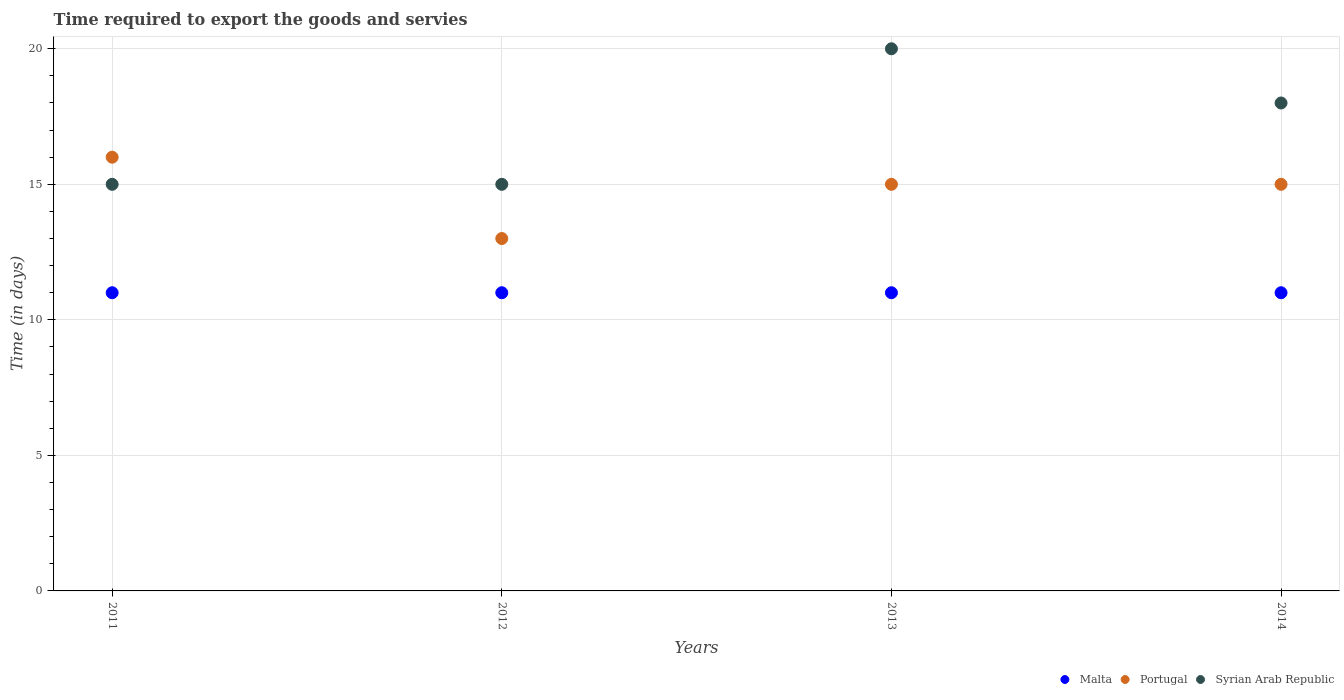How many different coloured dotlines are there?
Offer a terse response. 3. What is the number of days required to export the goods and services in Portugal in 2012?
Ensure brevity in your answer.  13. Across all years, what is the maximum number of days required to export the goods and services in Malta?
Keep it short and to the point. 11. In which year was the number of days required to export the goods and services in Malta minimum?
Keep it short and to the point. 2011. What is the total number of days required to export the goods and services in Portugal in the graph?
Your response must be concise. 59. In the year 2013, what is the difference between the number of days required to export the goods and services in Syrian Arab Republic and number of days required to export the goods and services in Portugal?
Keep it short and to the point. 5. In how many years, is the number of days required to export the goods and services in Syrian Arab Republic greater than 8 days?
Make the answer very short. 4. What is the ratio of the number of days required to export the goods and services in Syrian Arab Republic in 2012 to that in 2014?
Offer a terse response. 0.83. Is the number of days required to export the goods and services in Malta in 2011 less than that in 2014?
Your answer should be compact. No. What is the difference between the highest and the lowest number of days required to export the goods and services in Malta?
Your answer should be compact. 0. Is it the case that in every year, the sum of the number of days required to export the goods and services in Malta and number of days required to export the goods and services in Portugal  is greater than the number of days required to export the goods and services in Syrian Arab Republic?
Offer a terse response. Yes. Is the number of days required to export the goods and services in Malta strictly greater than the number of days required to export the goods and services in Portugal over the years?
Your answer should be compact. No. Is the number of days required to export the goods and services in Malta strictly less than the number of days required to export the goods and services in Syrian Arab Republic over the years?
Provide a short and direct response. Yes. How many dotlines are there?
Ensure brevity in your answer.  3. Are the values on the major ticks of Y-axis written in scientific E-notation?
Offer a very short reply. No. Does the graph contain any zero values?
Your answer should be compact. No. Does the graph contain grids?
Your response must be concise. Yes. Where does the legend appear in the graph?
Keep it short and to the point. Bottom right. What is the title of the graph?
Your answer should be very brief. Time required to export the goods and servies. Does "Kosovo" appear as one of the legend labels in the graph?
Ensure brevity in your answer.  No. What is the label or title of the X-axis?
Your response must be concise. Years. What is the label or title of the Y-axis?
Your response must be concise. Time (in days). What is the Time (in days) in Malta in 2011?
Make the answer very short. 11. What is the Time (in days) of Portugal in 2011?
Keep it short and to the point. 16. What is the Time (in days) in Syrian Arab Republic in 2011?
Make the answer very short. 15. What is the Time (in days) of Portugal in 2012?
Offer a very short reply. 13. What is the Time (in days) of Malta in 2013?
Ensure brevity in your answer.  11. What is the Time (in days) in Malta in 2014?
Your answer should be compact. 11. What is the Time (in days) of Portugal in 2014?
Your answer should be compact. 15. Across all years, what is the maximum Time (in days) in Malta?
Offer a terse response. 11. Across all years, what is the maximum Time (in days) of Portugal?
Your response must be concise. 16. What is the total Time (in days) in Malta in the graph?
Make the answer very short. 44. What is the total Time (in days) in Syrian Arab Republic in the graph?
Offer a terse response. 68. What is the difference between the Time (in days) in Malta in 2011 and that in 2012?
Give a very brief answer. 0. What is the difference between the Time (in days) in Malta in 2011 and that in 2013?
Your answer should be very brief. 0. What is the difference between the Time (in days) in Portugal in 2011 and that in 2013?
Keep it short and to the point. 1. What is the difference between the Time (in days) in Malta in 2011 and that in 2014?
Ensure brevity in your answer.  0. What is the difference between the Time (in days) of Syrian Arab Republic in 2011 and that in 2014?
Your answer should be compact. -3. What is the difference between the Time (in days) of Portugal in 2012 and that in 2013?
Your answer should be very brief. -2. What is the difference between the Time (in days) of Malta in 2012 and that in 2014?
Give a very brief answer. 0. What is the difference between the Time (in days) of Portugal in 2013 and that in 2014?
Your answer should be very brief. 0. What is the difference between the Time (in days) of Malta in 2011 and the Time (in days) of Syrian Arab Republic in 2012?
Your response must be concise. -4. What is the difference between the Time (in days) of Portugal in 2011 and the Time (in days) of Syrian Arab Republic in 2012?
Offer a very short reply. 1. What is the difference between the Time (in days) in Portugal in 2011 and the Time (in days) in Syrian Arab Republic in 2013?
Your answer should be compact. -4. What is the difference between the Time (in days) in Malta in 2011 and the Time (in days) in Portugal in 2014?
Provide a short and direct response. -4. What is the difference between the Time (in days) in Malta in 2011 and the Time (in days) in Syrian Arab Republic in 2014?
Your response must be concise. -7. What is the difference between the Time (in days) in Portugal in 2011 and the Time (in days) in Syrian Arab Republic in 2014?
Your response must be concise. -2. What is the difference between the Time (in days) in Malta in 2012 and the Time (in days) in Portugal in 2013?
Make the answer very short. -4. What is the difference between the Time (in days) of Malta in 2012 and the Time (in days) of Portugal in 2014?
Provide a succinct answer. -4. What is the difference between the Time (in days) in Portugal in 2012 and the Time (in days) in Syrian Arab Republic in 2014?
Keep it short and to the point. -5. What is the difference between the Time (in days) of Malta in 2013 and the Time (in days) of Portugal in 2014?
Your answer should be compact. -4. What is the difference between the Time (in days) in Malta in 2013 and the Time (in days) in Syrian Arab Republic in 2014?
Your response must be concise. -7. What is the average Time (in days) in Portugal per year?
Ensure brevity in your answer.  14.75. What is the average Time (in days) of Syrian Arab Republic per year?
Provide a short and direct response. 17. In the year 2011, what is the difference between the Time (in days) in Malta and Time (in days) in Syrian Arab Republic?
Provide a succinct answer. -4. In the year 2012, what is the difference between the Time (in days) in Malta and Time (in days) in Portugal?
Your answer should be very brief. -2. In the year 2012, what is the difference between the Time (in days) in Portugal and Time (in days) in Syrian Arab Republic?
Make the answer very short. -2. In the year 2013, what is the difference between the Time (in days) in Malta and Time (in days) in Syrian Arab Republic?
Provide a succinct answer. -9. In the year 2014, what is the difference between the Time (in days) of Malta and Time (in days) of Portugal?
Give a very brief answer. -4. In the year 2014, what is the difference between the Time (in days) of Malta and Time (in days) of Syrian Arab Republic?
Offer a very short reply. -7. In the year 2014, what is the difference between the Time (in days) of Portugal and Time (in days) of Syrian Arab Republic?
Offer a terse response. -3. What is the ratio of the Time (in days) in Malta in 2011 to that in 2012?
Offer a very short reply. 1. What is the ratio of the Time (in days) of Portugal in 2011 to that in 2012?
Provide a short and direct response. 1.23. What is the ratio of the Time (in days) in Syrian Arab Republic in 2011 to that in 2012?
Your answer should be compact. 1. What is the ratio of the Time (in days) of Malta in 2011 to that in 2013?
Your response must be concise. 1. What is the ratio of the Time (in days) of Portugal in 2011 to that in 2013?
Your answer should be very brief. 1.07. What is the ratio of the Time (in days) in Syrian Arab Republic in 2011 to that in 2013?
Provide a succinct answer. 0.75. What is the ratio of the Time (in days) in Malta in 2011 to that in 2014?
Your answer should be compact. 1. What is the ratio of the Time (in days) of Portugal in 2011 to that in 2014?
Ensure brevity in your answer.  1.07. What is the ratio of the Time (in days) in Malta in 2012 to that in 2013?
Your answer should be very brief. 1. What is the ratio of the Time (in days) in Portugal in 2012 to that in 2013?
Ensure brevity in your answer.  0.87. What is the ratio of the Time (in days) in Syrian Arab Republic in 2012 to that in 2013?
Give a very brief answer. 0.75. What is the ratio of the Time (in days) of Portugal in 2012 to that in 2014?
Your answer should be very brief. 0.87. What is the ratio of the Time (in days) in Portugal in 2013 to that in 2014?
Offer a very short reply. 1. What is the difference between the highest and the second highest Time (in days) in Portugal?
Provide a short and direct response. 1. What is the difference between the highest and the lowest Time (in days) of Portugal?
Your response must be concise. 3. What is the difference between the highest and the lowest Time (in days) in Syrian Arab Republic?
Your answer should be compact. 5. 